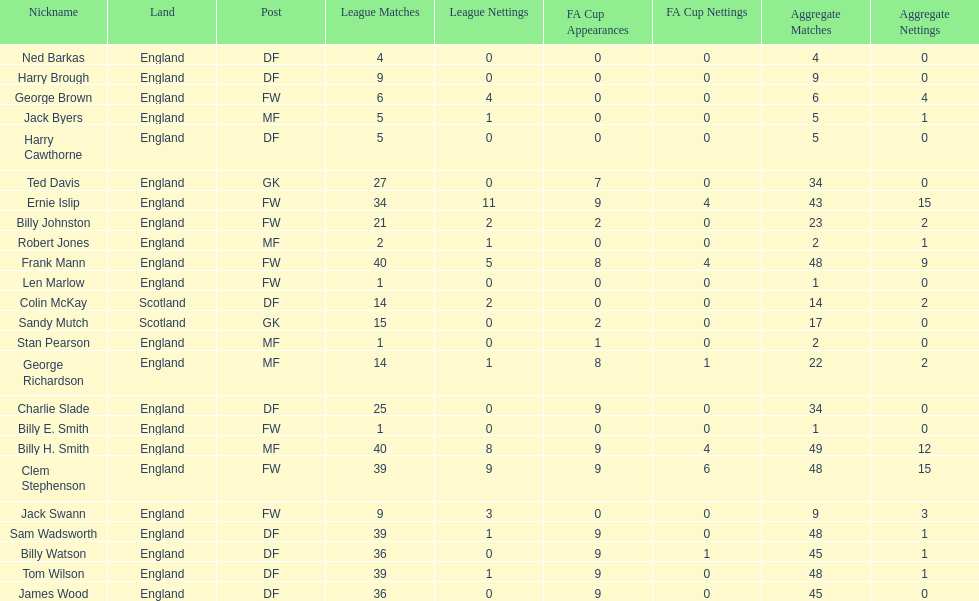What is the first name listed? Ned Barkas. 